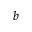<formula> <loc_0><loc_0><loc_500><loc_500>b</formula> 